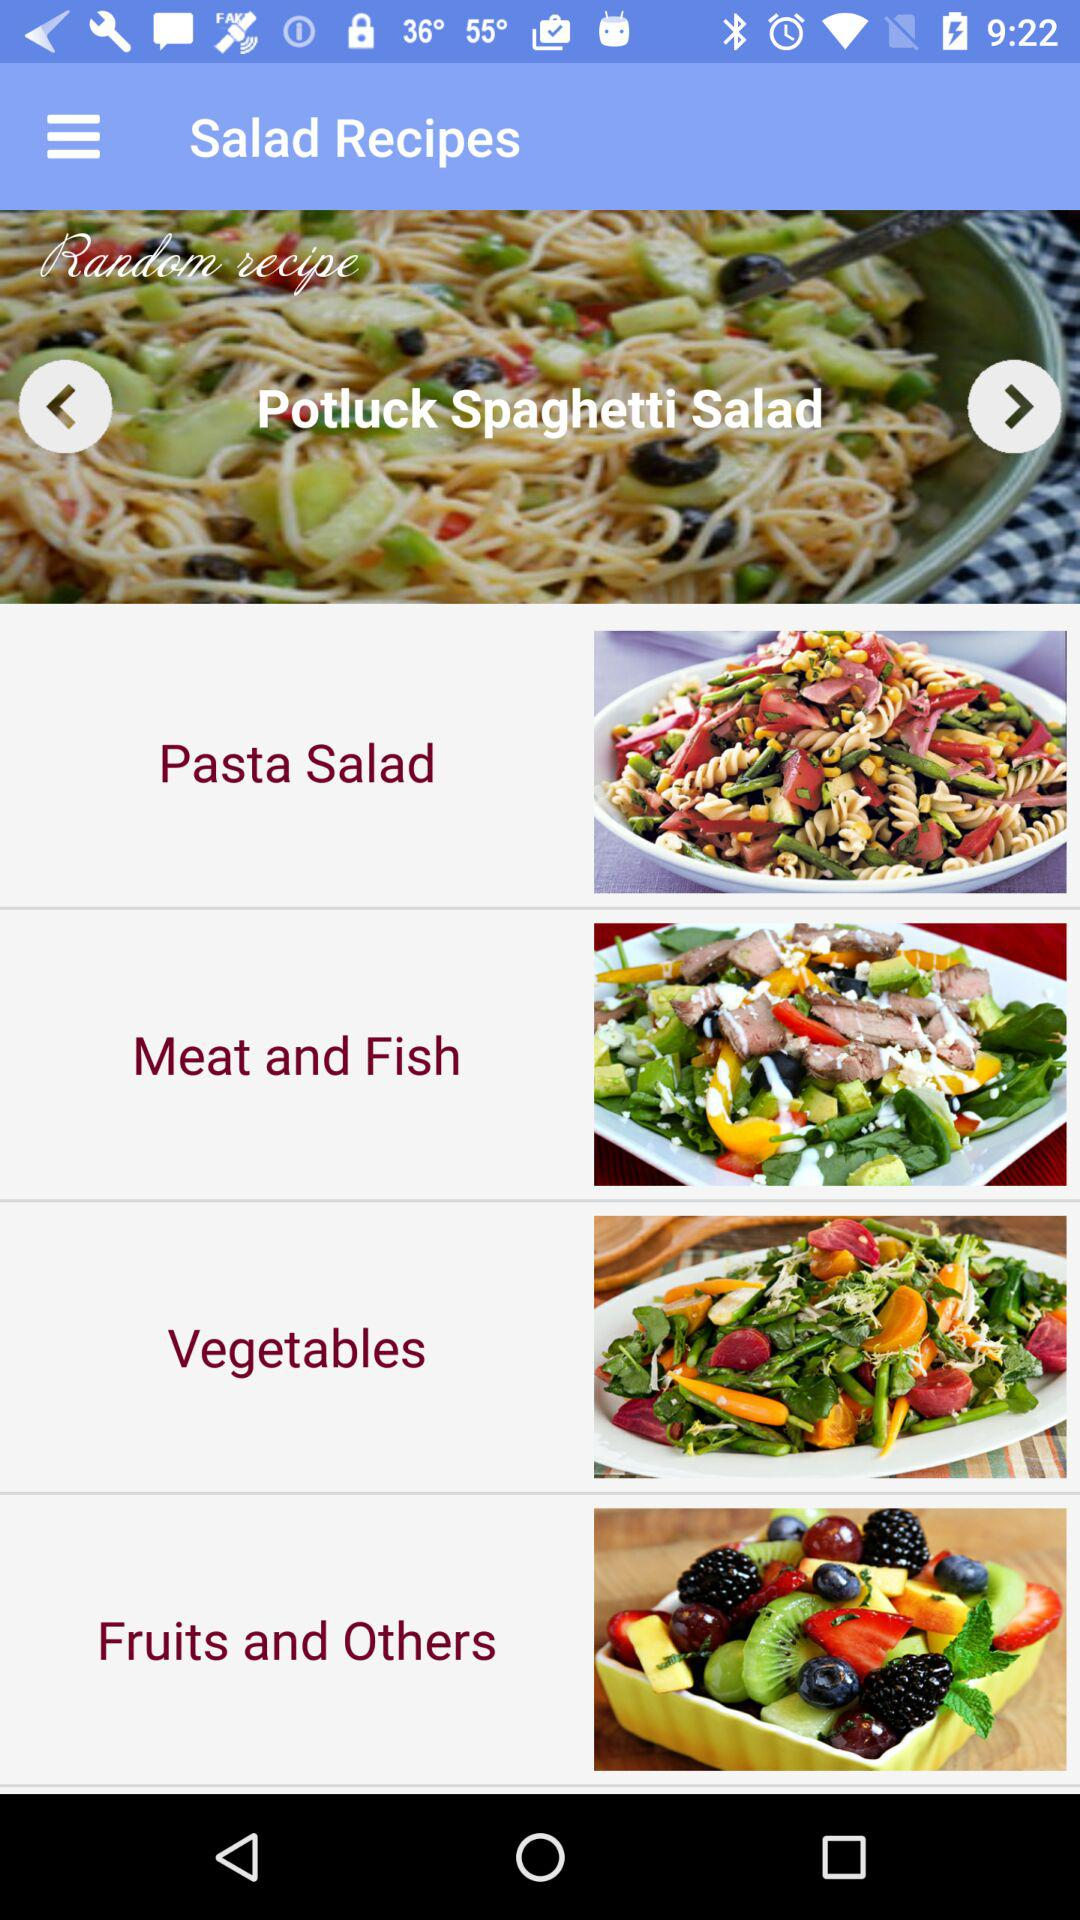How many salad recipes are there?
Answer the question using a single word or phrase. 4 